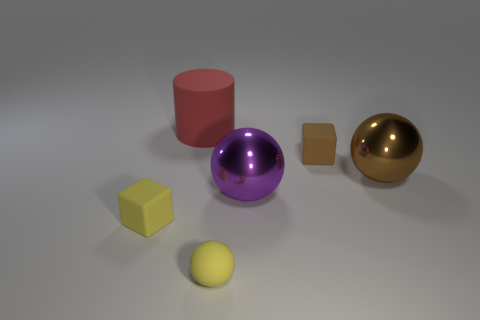Add 4 small balls. How many objects exist? 10 Subtract all blocks. How many objects are left? 4 Subtract all large purple rubber things. Subtract all large objects. How many objects are left? 3 Add 2 brown shiny things. How many brown shiny things are left? 3 Add 5 red matte cylinders. How many red matte cylinders exist? 6 Subtract 0 green cubes. How many objects are left? 6 